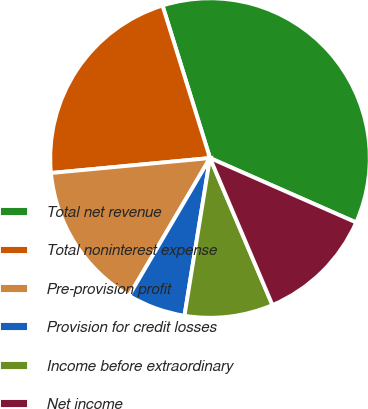Convert chart. <chart><loc_0><loc_0><loc_500><loc_500><pie_chart><fcel>Total net revenue<fcel>Total noninterest expense<fcel>Pre-provision profit<fcel>Provision for credit losses<fcel>Income before extraordinary<fcel>Net income<nl><fcel>36.41%<fcel>21.69%<fcel>15.05%<fcel>5.9%<fcel>8.95%<fcel>12.0%<nl></chart> 